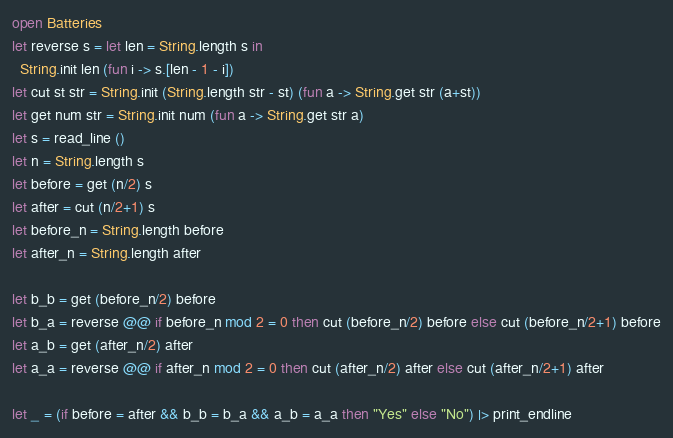<code> <loc_0><loc_0><loc_500><loc_500><_OCaml_>open Batteries
let reverse s = let len = String.length s in
  String.init len (fun i -> s.[len - 1 - i])
let cut st str = String.init (String.length str - st) (fun a -> String.get str (a+st))
let get num str = String.init num (fun a -> String.get str a)
let s = read_line ()
let n = String.length s
let before = get (n/2) s
let after = cut (n/2+1) s
let before_n = String.length before
let after_n = String.length after

let b_b = get (before_n/2) before
let b_a = reverse @@ if before_n mod 2 = 0 then cut (before_n/2) before else cut (before_n/2+1) before
let a_b = get (after_n/2) after
let a_a = reverse @@ if after_n mod 2 = 0 then cut (after_n/2) after else cut (after_n/2+1) after

let _ = (if before = after && b_b = b_a && a_b = a_a then "Yes" else "No") |> print_endline
</code> 